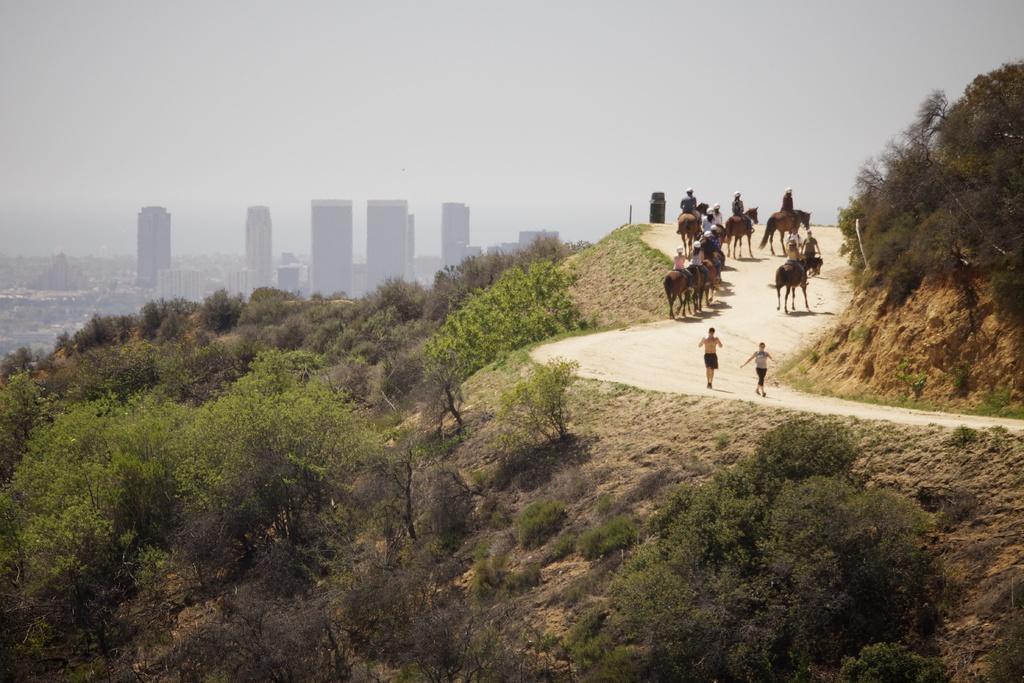Can you describe this image briefly? In this image I can see few horses and few people are sitting on it. The horse is in brown color. I can see trees on both-sides. Back I can see buildings. The sky is in white color. 